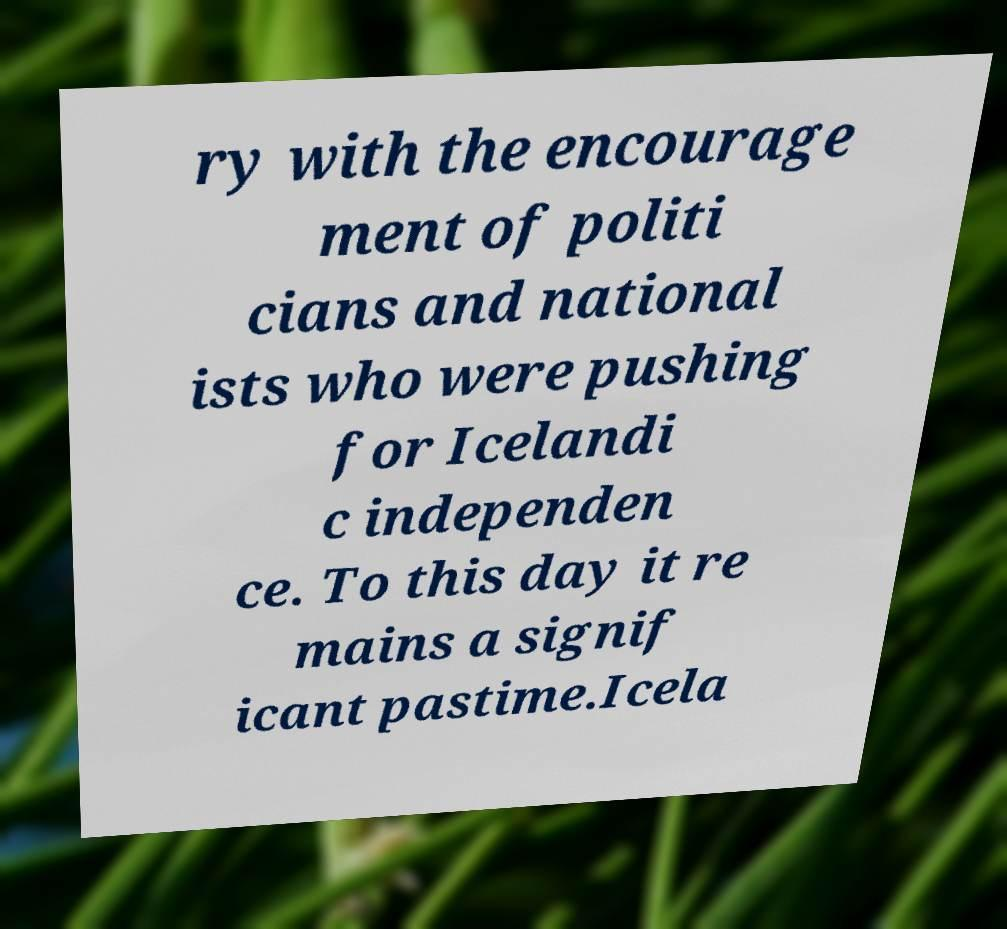Can you read and provide the text displayed in the image?This photo seems to have some interesting text. Can you extract and type it out for me? ry with the encourage ment of politi cians and national ists who were pushing for Icelandi c independen ce. To this day it re mains a signif icant pastime.Icela 